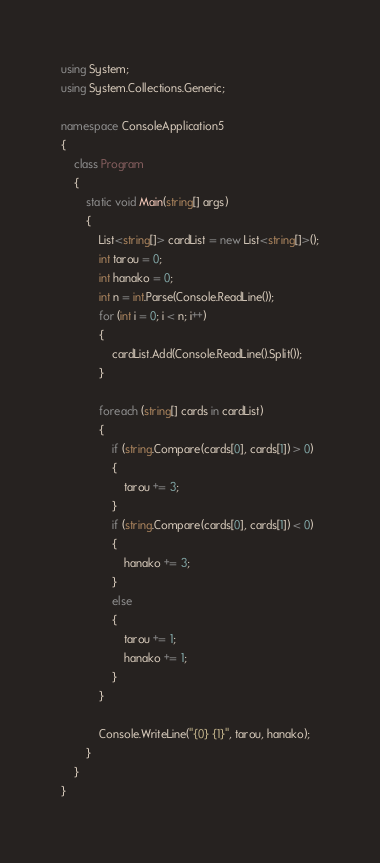<code> <loc_0><loc_0><loc_500><loc_500><_C#_>using System;
using System.Collections.Generic;

namespace ConsoleApplication5
{
    class Program
    {
        static void Main(string[] args)
        {
            List<string[]> cardList = new List<string[]>();
            int tarou = 0;
            int hanako = 0;
            int n = int.Parse(Console.ReadLine());
            for (int i = 0; i < n; i++)
            {
                cardList.Add(Console.ReadLine().Split());
            }

            foreach (string[] cards in cardList)
            {
                if (string.Compare(cards[0], cards[1]) > 0)
                {
                    tarou += 3;
                }
                if (string.Compare(cards[0], cards[1]) < 0)
                {
                    hanako += 3;
                }
                else
                {
                    tarou += 1;
                    hanako += 1;
                }
            }

            Console.WriteLine("{0} {1}", tarou, hanako);
        }
    }
}</code> 